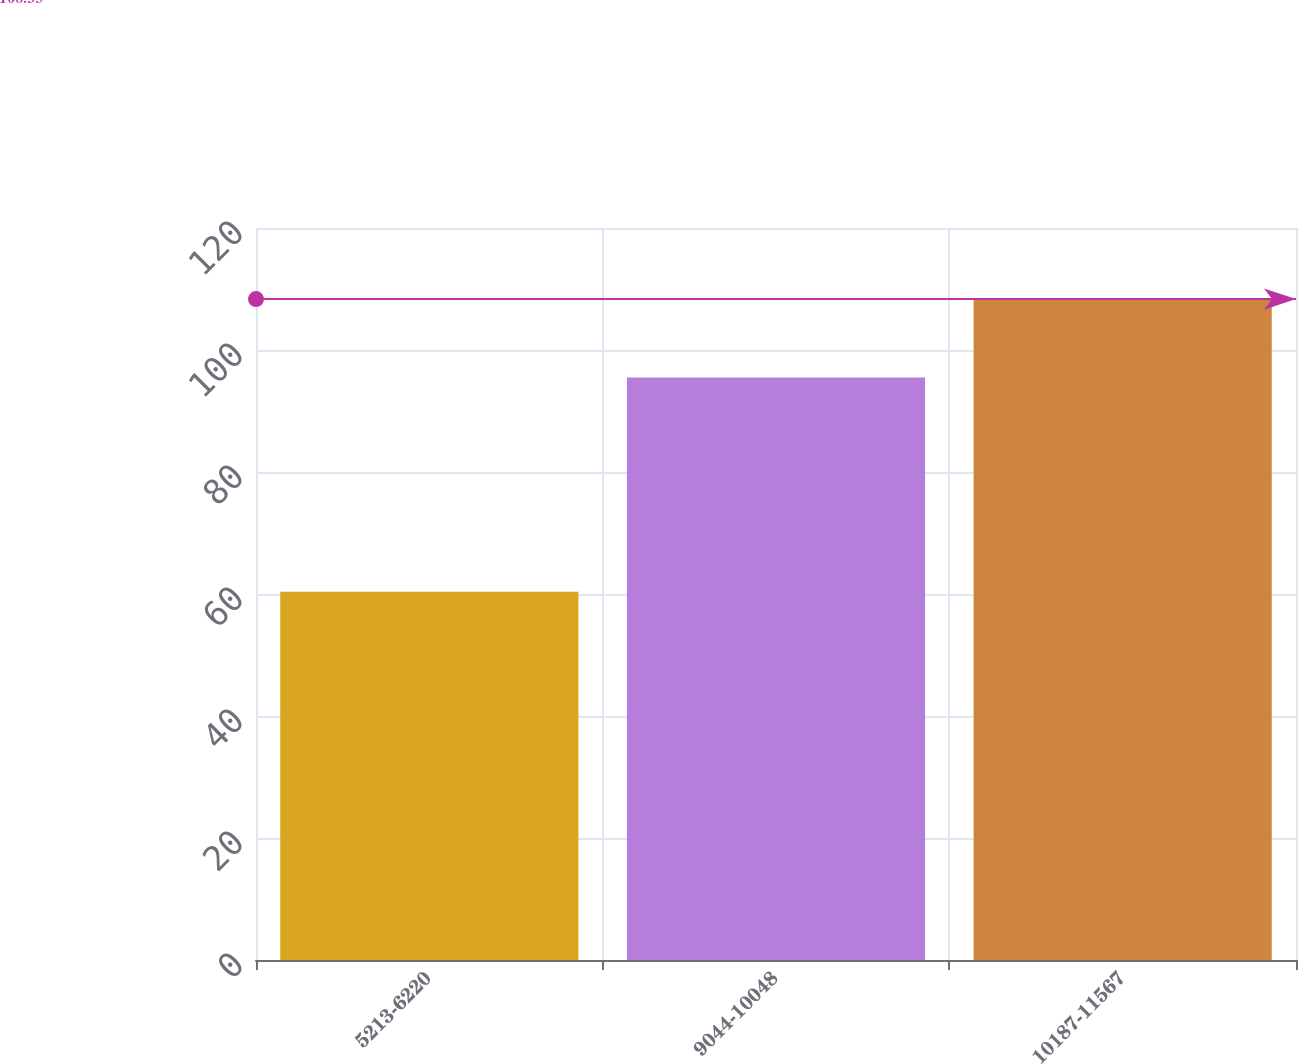Convert chart to OTSL. <chart><loc_0><loc_0><loc_500><loc_500><bar_chart><fcel>5213-6220<fcel>9044-10048<fcel>10187-11567<nl><fcel>60.37<fcel>95.48<fcel>108.35<nl></chart> 